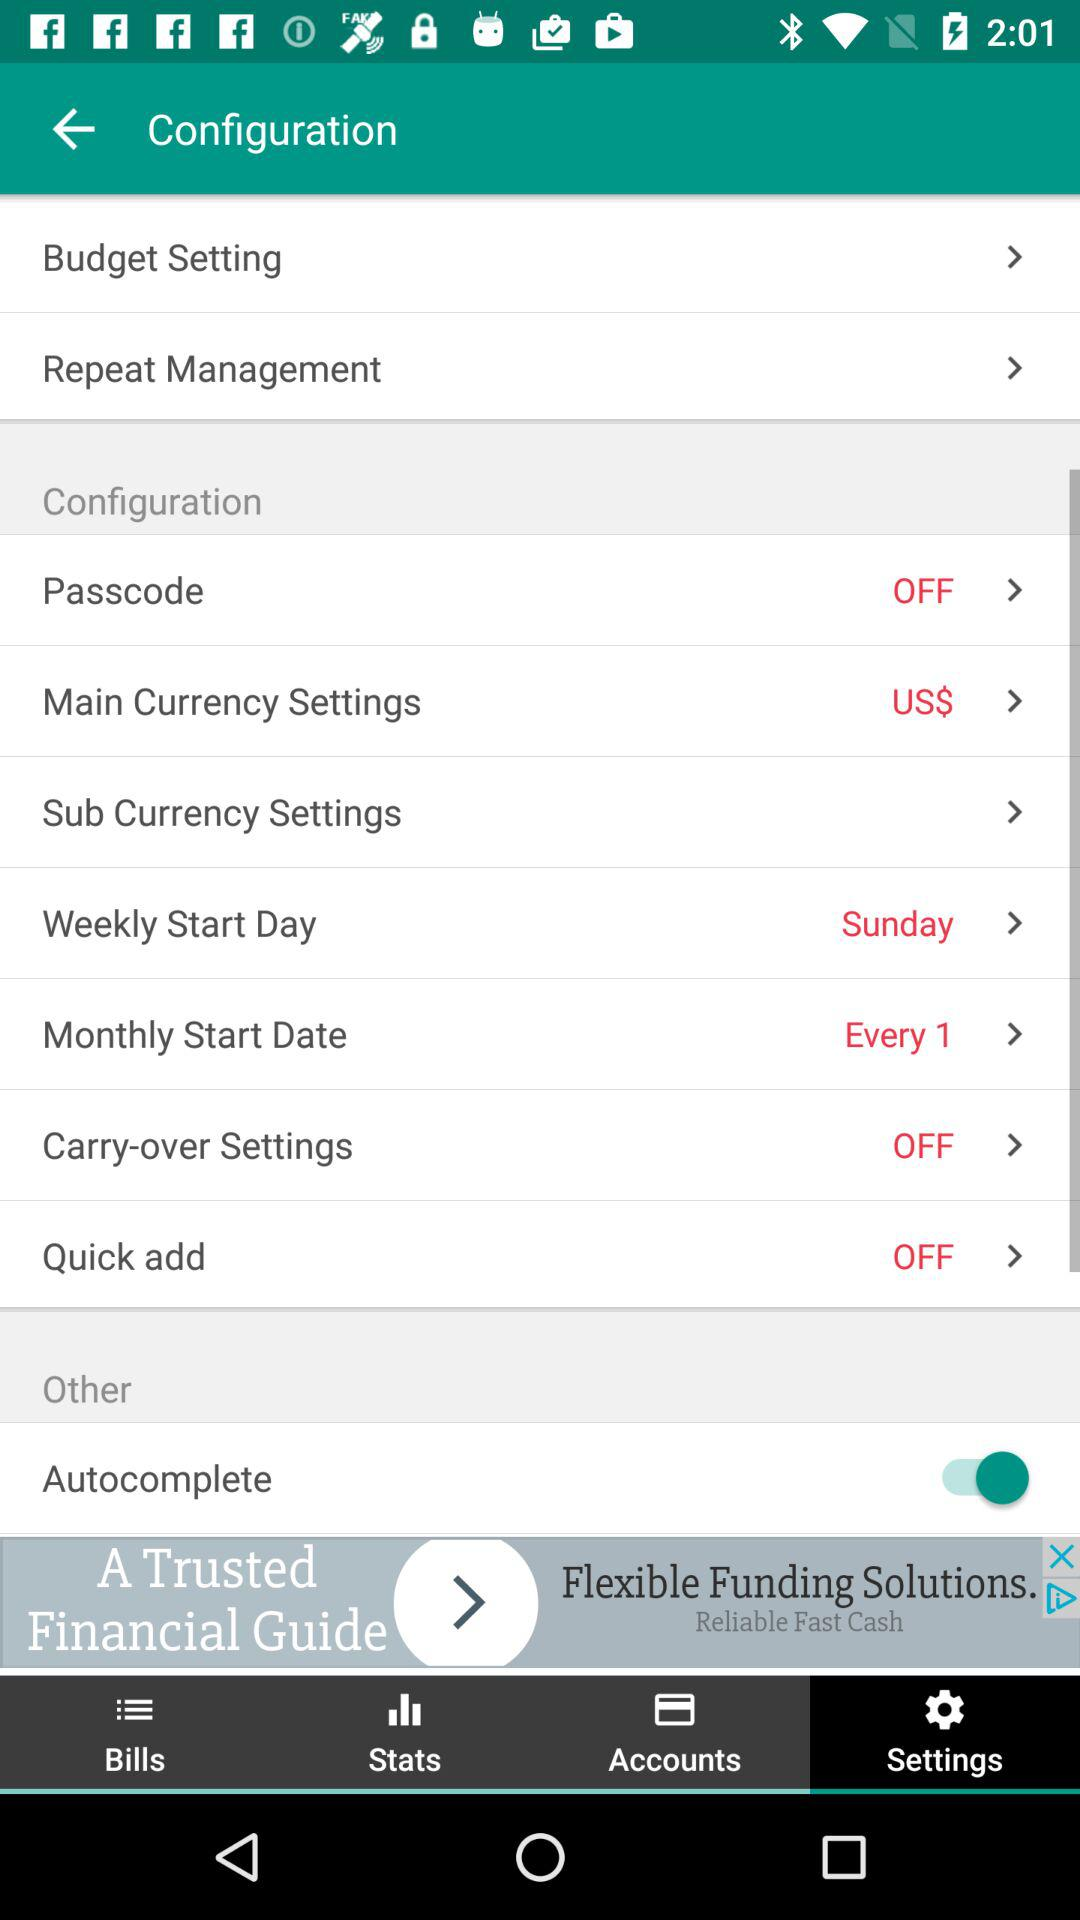What is the weekly start day? The weekly start day is Sunday. 